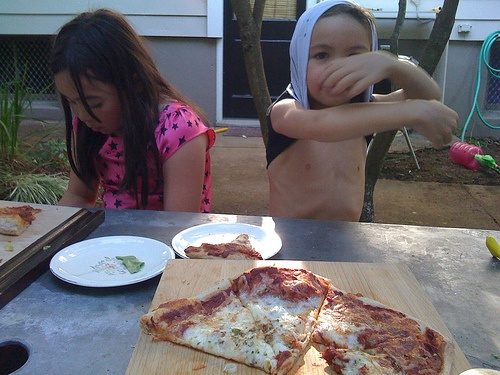Describe the objects in this image and their specific colors. I can see dining table in gray and darkgray tones, people in gray, black, maroon, brown, and purple tones, people in gray and black tones, pizza in gray, darkgray, and brown tones, and pizza in gray, brown, darkgray, and maroon tones in this image. 